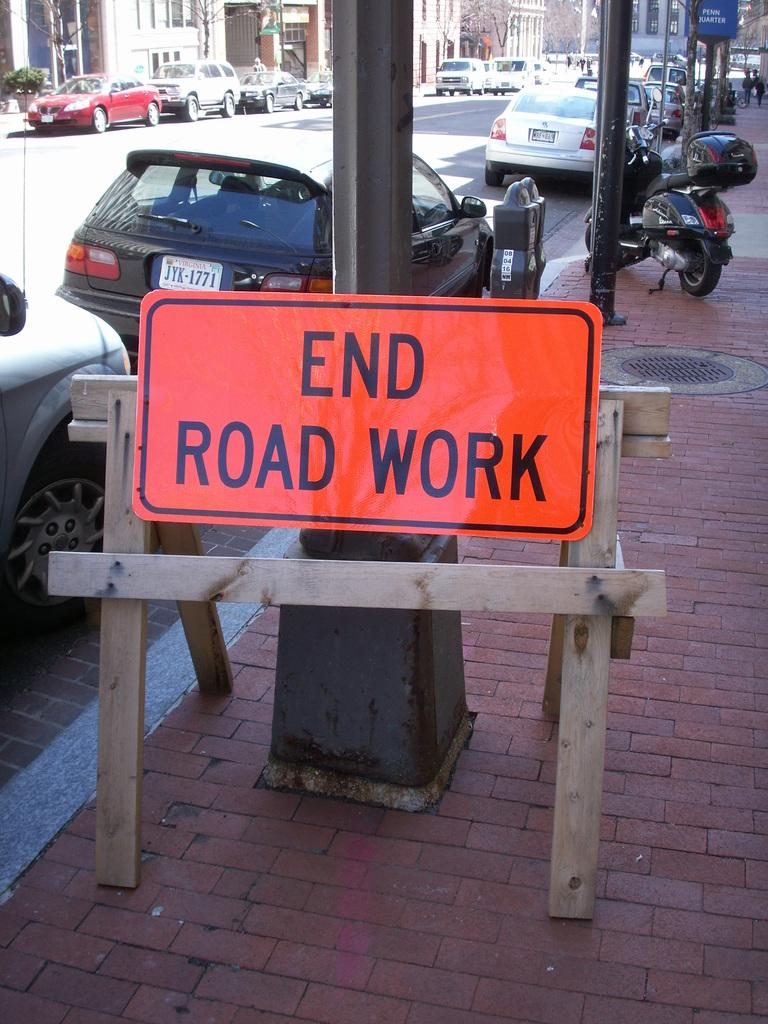What type of structures can be seen in the image? There are buildings in the image. What feature is visible on the buildings? There are windows visible in the image. What type of natural elements are present in the image? There are trees in the image. What additional objects can be seen in the image? There are boards and poles in the image. What else is present in the image? There are objects and vehicles on the road in the image. How many spiders are crawling on the buildings in the image? There are no spiders visible in the image. What reward is being given to the fireman in the image? There is no fireman or reward present in the image. 